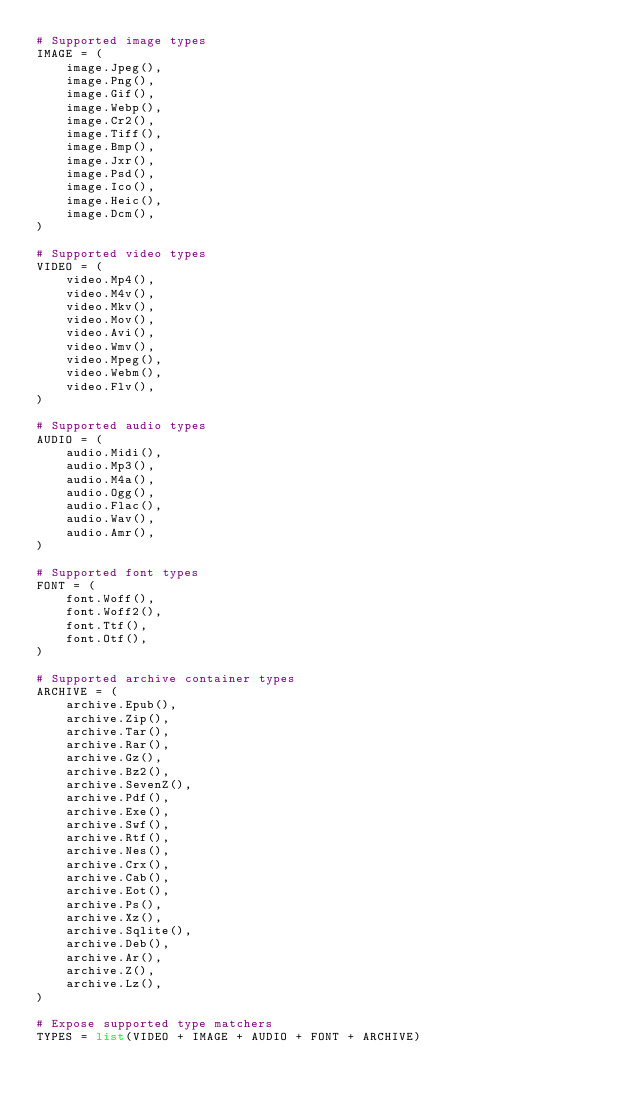Convert code to text. <code><loc_0><loc_0><loc_500><loc_500><_Python_># Supported image types
IMAGE = (
    image.Jpeg(),
    image.Png(),
    image.Gif(),
    image.Webp(),
    image.Cr2(),
    image.Tiff(),
    image.Bmp(),
    image.Jxr(),
    image.Psd(),
    image.Ico(),
    image.Heic(),
    image.Dcm(),
)

# Supported video types
VIDEO = (
    video.Mp4(),
    video.M4v(),
    video.Mkv(),
    video.Mov(),
    video.Avi(),
    video.Wmv(),
    video.Mpeg(),
    video.Webm(),
    video.Flv(),
)

# Supported audio types
AUDIO = (
    audio.Midi(),
    audio.Mp3(),
    audio.M4a(),
    audio.Ogg(),
    audio.Flac(),
    audio.Wav(),
    audio.Amr(),
)

# Supported font types
FONT = (
    font.Woff(),
    font.Woff2(),
    font.Ttf(),
    font.Otf(),
)

# Supported archive container types
ARCHIVE = (
    archive.Epub(),
    archive.Zip(),
    archive.Tar(),
    archive.Rar(),
    archive.Gz(),
    archive.Bz2(),
    archive.SevenZ(),
    archive.Pdf(),
    archive.Exe(),
    archive.Swf(),
    archive.Rtf(),
    archive.Nes(),
    archive.Crx(),
    archive.Cab(),
    archive.Eot(),
    archive.Ps(),
    archive.Xz(),
    archive.Sqlite(),
    archive.Deb(),
    archive.Ar(),
    archive.Z(),
    archive.Lz(),
)

# Expose supported type matchers
TYPES = list(VIDEO + IMAGE + AUDIO + FONT + ARCHIVE)
</code> 